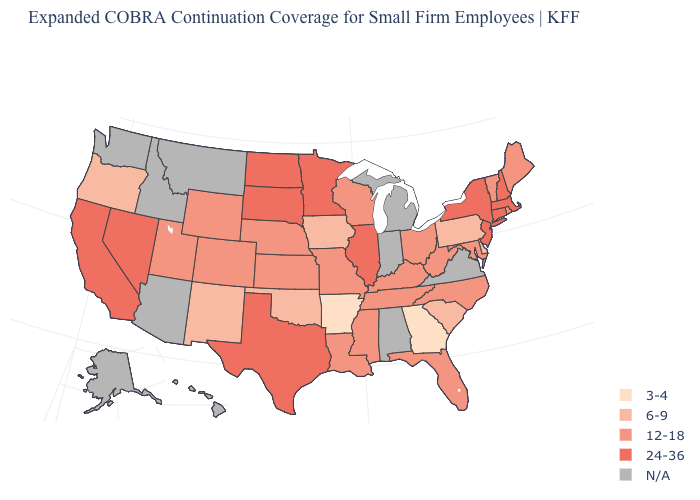Does Massachusetts have the highest value in the USA?
Write a very short answer. Yes. Name the states that have a value in the range N/A?
Give a very brief answer. Alabama, Alaska, Arizona, Hawaii, Idaho, Indiana, Michigan, Montana, Virginia, Washington. What is the lowest value in the West?
Concise answer only. 6-9. Does Vermont have the highest value in the USA?
Write a very short answer. No. Name the states that have a value in the range N/A?
Give a very brief answer. Alabama, Alaska, Arizona, Hawaii, Idaho, Indiana, Michigan, Montana, Virginia, Washington. Does Vermont have the highest value in the USA?
Quick response, please. No. Which states hav the highest value in the South?
Quick response, please. Texas. What is the lowest value in states that border Indiana?
Write a very short answer. 12-18. What is the value of West Virginia?
Give a very brief answer. 12-18. Name the states that have a value in the range N/A?
Short answer required. Alabama, Alaska, Arizona, Hawaii, Idaho, Indiana, Michigan, Montana, Virginia, Washington. What is the value of California?
Answer briefly. 24-36. Does New York have the highest value in the USA?
Concise answer only. Yes. Name the states that have a value in the range 6-9?
Be succinct. Delaware, Iowa, New Mexico, Oklahoma, Oregon, Pennsylvania, South Carolina. 